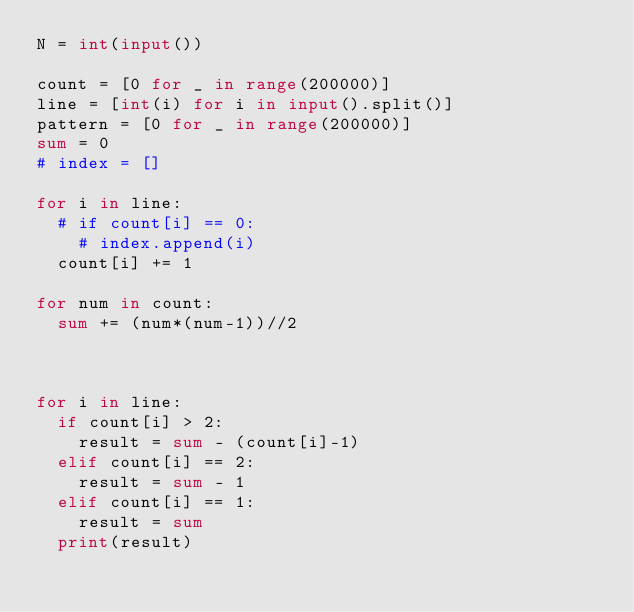<code> <loc_0><loc_0><loc_500><loc_500><_Python_>N = int(input())

count = [0 for _ in range(200000)]
line = [int(i) for i in input().split()]
pattern = [0 for _ in range(200000)]
sum = 0
# index = []

for i in line:
	# if count[i] == 0:
		# index.append(i)
	count[i] += 1

for num in count:
	sum += (num*(num-1))//2



for i in line:
	if count[i] > 2:
		result = sum - (count[i]-1) 
	elif count[i] == 2:
		result = sum - 1
	elif count[i] == 1:
		result = sum
	print(result) 
</code> 